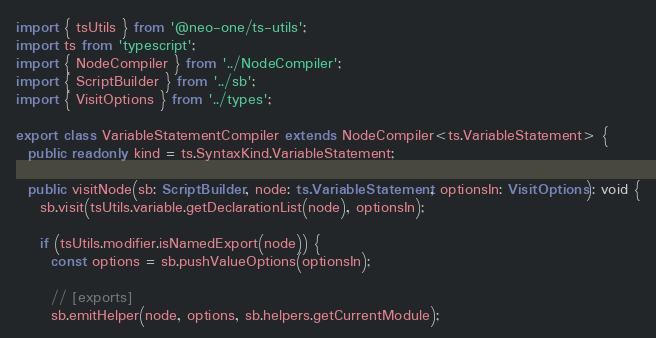<code> <loc_0><loc_0><loc_500><loc_500><_TypeScript_>import { tsUtils } from '@neo-one/ts-utils';
import ts from 'typescript';
import { NodeCompiler } from '../NodeCompiler';
import { ScriptBuilder } from '../sb';
import { VisitOptions } from '../types';

export class VariableStatementCompiler extends NodeCompiler<ts.VariableStatement> {
  public readonly kind = ts.SyntaxKind.VariableStatement;

  public visitNode(sb: ScriptBuilder, node: ts.VariableStatement, optionsIn: VisitOptions): void {
    sb.visit(tsUtils.variable.getDeclarationList(node), optionsIn);

    if (tsUtils.modifier.isNamedExport(node)) {
      const options = sb.pushValueOptions(optionsIn);

      // [exports]
      sb.emitHelper(node, options, sb.helpers.getCurrentModule);</code> 